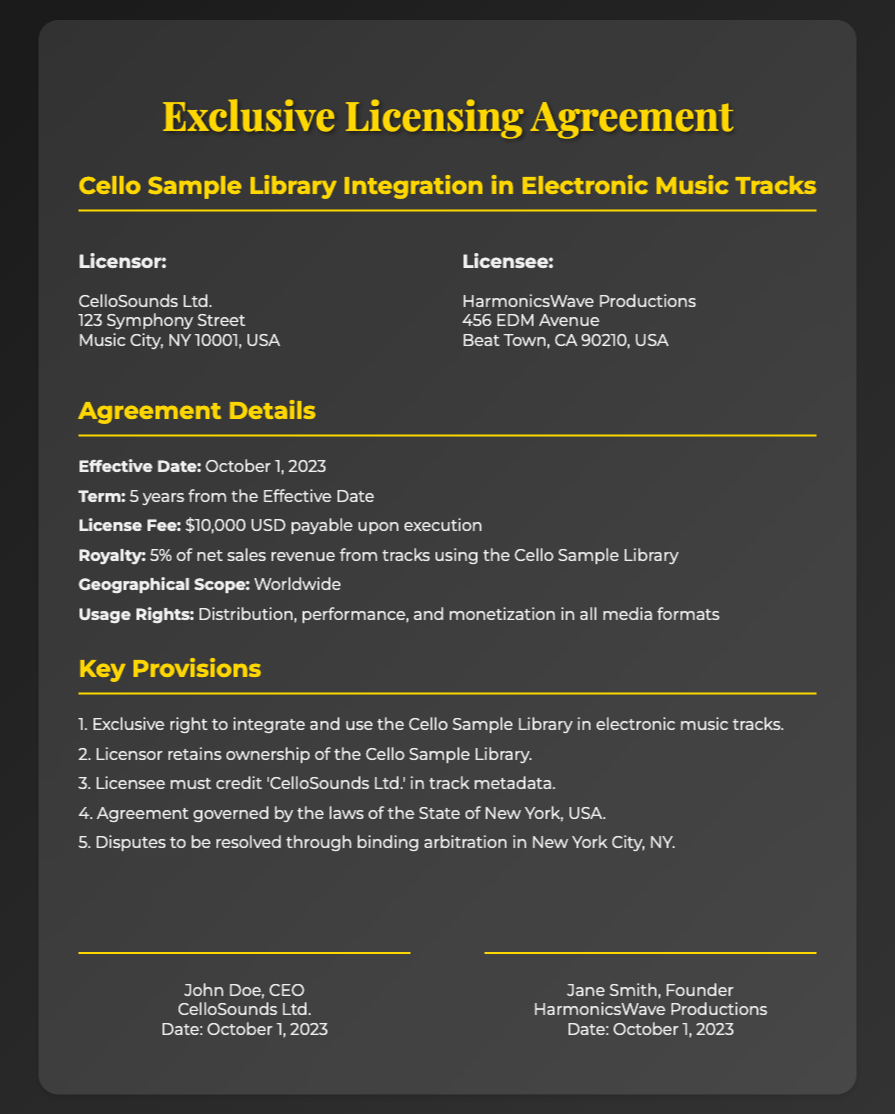What is the name of the Licensor? The document states that the Licensor is CelloSounds Ltd.
Answer: CelloSounds Ltd What is the effective date of the agreement? The effective date is explicitly mentioned in the document as October 1, 2023.
Answer: October 1, 2023 What is the license fee mentioned in the agreement? The document specifies the license fee as $10,000 USD payable upon execution.
Answer: $10,000 USD What is the geographical scope of the licensing agreement? The geographical scope is defined in the document as Worldwide.
Answer: Worldwide What percentage royalty is stated for the net sales revenue? The document states that the royalty is 5% of net sales revenue from tracks using the Cello Sample Library.
Answer: 5% How long is the term of the agreement? The term of the agreement, as listed in the document, is 5 years from the Effective Date.
Answer: 5 years Where will disputes be resolved according to the document? The agreement specifies that disputes will be resolved through binding arbitration in New York City, NY.
Answer: New York City, NY What is the party that must be credited in track metadata? The document states that the Licensee must credit 'CelloSounds Ltd.' in track metadata.
Answer: CelloSounds Ltd 